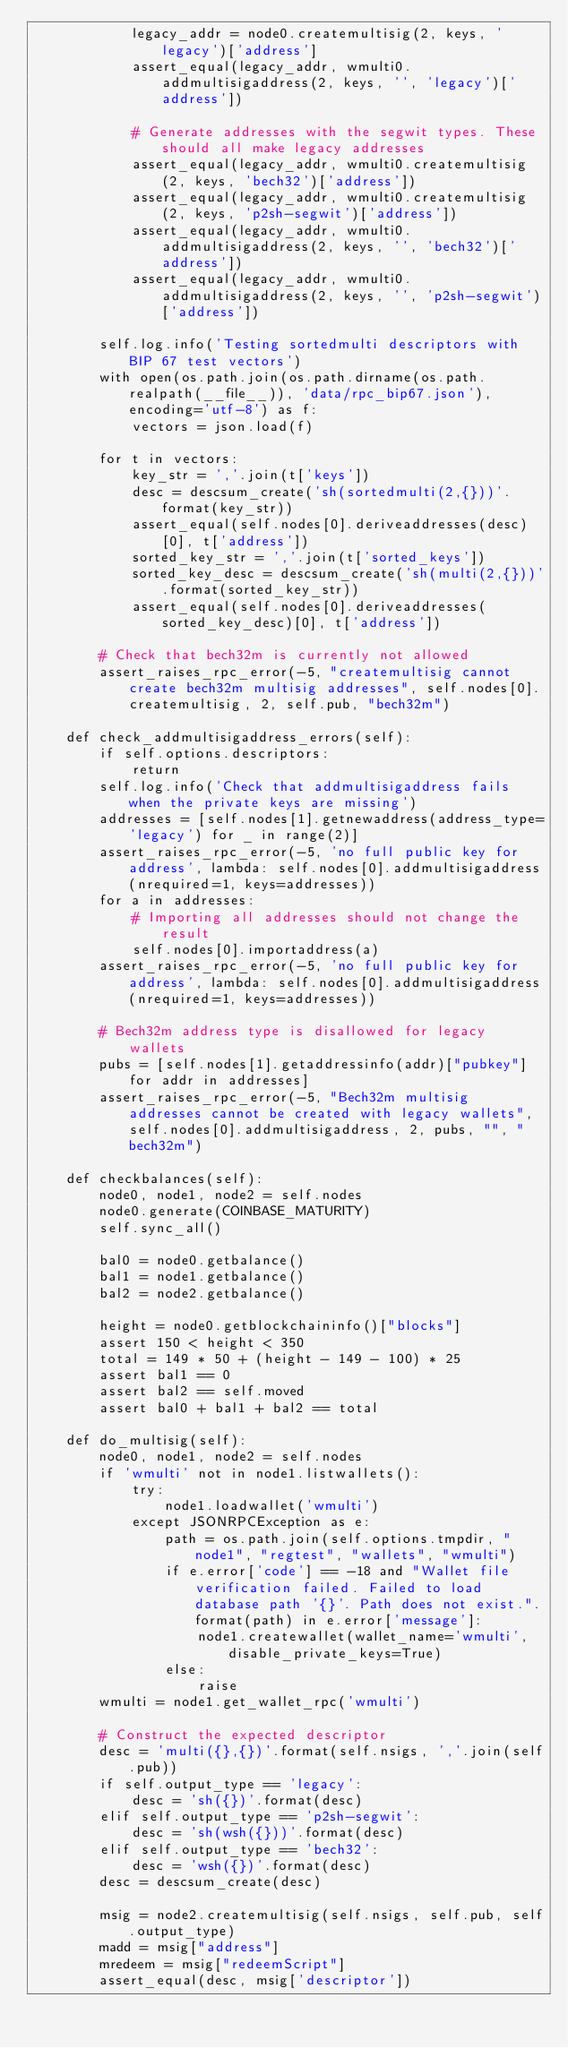<code> <loc_0><loc_0><loc_500><loc_500><_Python_>            legacy_addr = node0.createmultisig(2, keys, 'legacy')['address']
            assert_equal(legacy_addr, wmulti0.addmultisigaddress(2, keys, '', 'legacy')['address'])

            # Generate addresses with the segwit types. These should all make legacy addresses
            assert_equal(legacy_addr, wmulti0.createmultisig(2, keys, 'bech32')['address'])
            assert_equal(legacy_addr, wmulti0.createmultisig(2, keys, 'p2sh-segwit')['address'])
            assert_equal(legacy_addr, wmulti0.addmultisigaddress(2, keys, '', 'bech32')['address'])
            assert_equal(legacy_addr, wmulti0.addmultisigaddress(2, keys, '', 'p2sh-segwit')['address'])

        self.log.info('Testing sortedmulti descriptors with BIP 67 test vectors')
        with open(os.path.join(os.path.dirname(os.path.realpath(__file__)), 'data/rpc_bip67.json'), encoding='utf-8') as f:
            vectors = json.load(f)

        for t in vectors:
            key_str = ','.join(t['keys'])
            desc = descsum_create('sh(sortedmulti(2,{}))'.format(key_str))
            assert_equal(self.nodes[0].deriveaddresses(desc)[0], t['address'])
            sorted_key_str = ','.join(t['sorted_keys'])
            sorted_key_desc = descsum_create('sh(multi(2,{}))'.format(sorted_key_str))
            assert_equal(self.nodes[0].deriveaddresses(sorted_key_desc)[0], t['address'])

        # Check that bech32m is currently not allowed
        assert_raises_rpc_error(-5, "createmultisig cannot create bech32m multisig addresses", self.nodes[0].createmultisig, 2, self.pub, "bech32m")

    def check_addmultisigaddress_errors(self):
        if self.options.descriptors:
            return
        self.log.info('Check that addmultisigaddress fails when the private keys are missing')
        addresses = [self.nodes[1].getnewaddress(address_type='legacy') for _ in range(2)]
        assert_raises_rpc_error(-5, 'no full public key for address', lambda: self.nodes[0].addmultisigaddress(nrequired=1, keys=addresses))
        for a in addresses:
            # Importing all addresses should not change the result
            self.nodes[0].importaddress(a)
        assert_raises_rpc_error(-5, 'no full public key for address', lambda: self.nodes[0].addmultisigaddress(nrequired=1, keys=addresses))

        # Bech32m address type is disallowed for legacy wallets
        pubs = [self.nodes[1].getaddressinfo(addr)["pubkey"] for addr in addresses]
        assert_raises_rpc_error(-5, "Bech32m multisig addresses cannot be created with legacy wallets", self.nodes[0].addmultisigaddress, 2, pubs, "", "bech32m")

    def checkbalances(self):
        node0, node1, node2 = self.nodes
        node0.generate(COINBASE_MATURITY)
        self.sync_all()

        bal0 = node0.getbalance()
        bal1 = node1.getbalance()
        bal2 = node2.getbalance()

        height = node0.getblockchaininfo()["blocks"]
        assert 150 < height < 350
        total = 149 * 50 + (height - 149 - 100) * 25
        assert bal1 == 0
        assert bal2 == self.moved
        assert bal0 + bal1 + bal2 == total

    def do_multisig(self):
        node0, node1, node2 = self.nodes
        if 'wmulti' not in node1.listwallets():
            try:
                node1.loadwallet('wmulti')
            except JSONRPCException as e:
                path = os.path.join(self.options.tmpdir, "node1", "regtest", "wallets", "wmulti")
                if e.error['code'] == -18 and "Wallet file verification failed. Failed to load database path '{}'. Path does not exist.".format(path) in e.error['message']:
                    node1.createwallet(wallet_name='wmulti', disable_private_keys=True)
                else:
                    raise
        wmulti = node1.get_wallet_rpc('wmulti')

        # Construct the expected descriptor
        desc = 'multi({},{})'.format(self.nsigs, ','.join(self.pub))
        if self.output_type == 'legacy':
            desc = 'sh({})'.format(desc)
        elif self.output_type == 'p2sh-segwit':
            desc = 'sh(wsh({}))'.format(desc)
        elif self.output_type == 'bech32':
            desc = 'wsh({})'.format(desc)
        desc = descsum_create(desc)

        msig = node2.createmultisig(self.nsigs, self.pub, self.output_type)
        madd = msig["address"]
        mredeem = msig["redeemScript"]
        assert_equal(desc, msig['descriptor'])</code> 